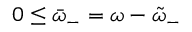<formula> <loc_0><loc_0><loc_500><loc_500>0 \leq \bar { \omega } _ { - } = \omega - \tilde { \omega } _ { - }</formula> 